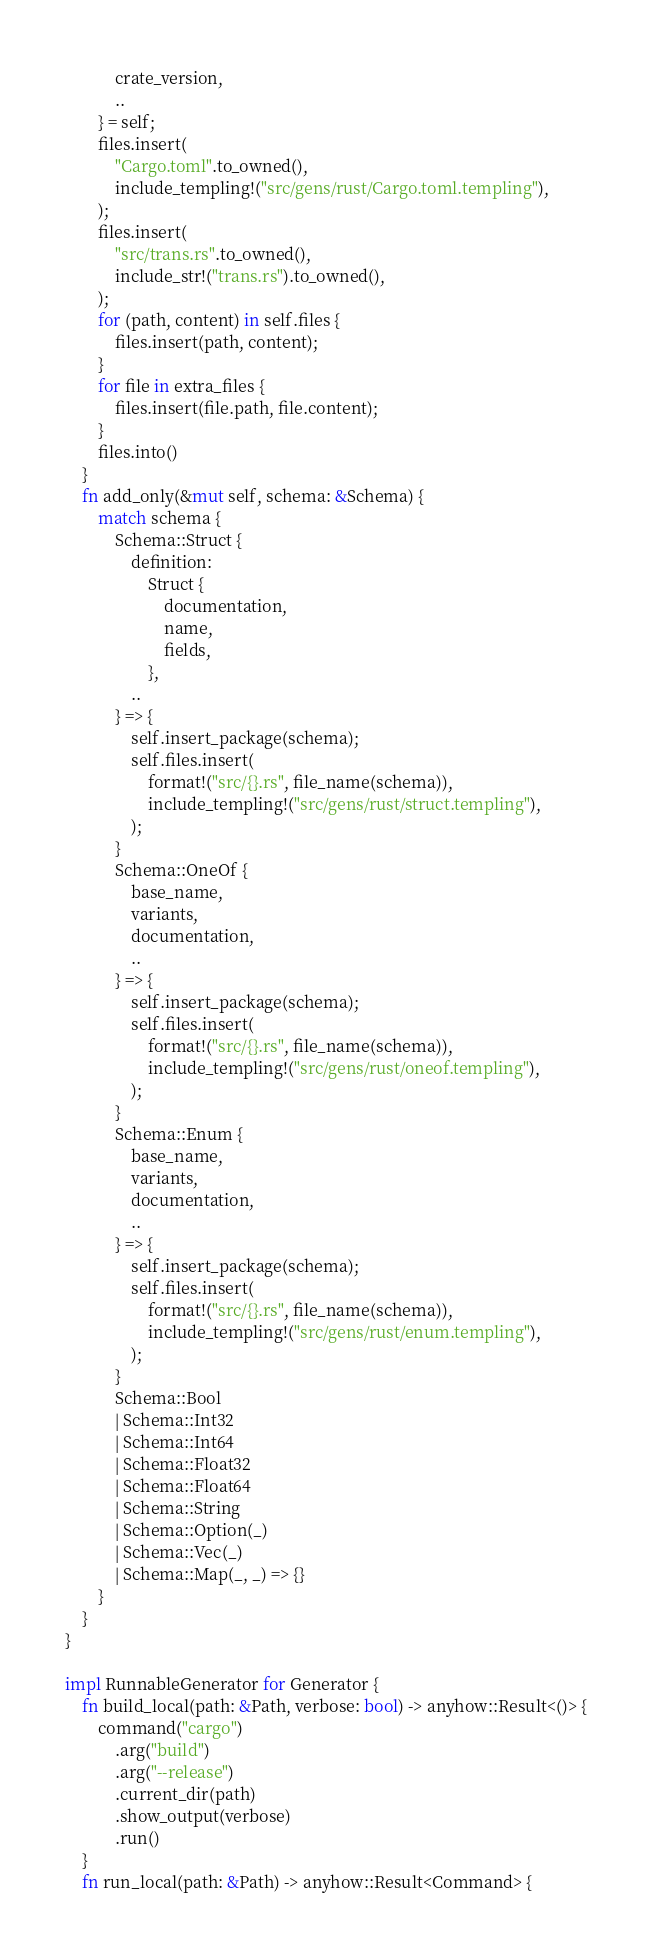<code> <loc_0><loc_0><loc_500><loc_500><_Rust_>            crate_version,
            ..
        } = self;
        files.insert(
            "Cargo.toml".to_owned(),
            include_templing!("src/gens/rust/Cargo.toml.templing"),
        );
        files.insert(
            "src/trans.rs".to_owned(),
            include_str!("trans.rs").to_owned(),
        );
        for (path, content) in self.files {
            files.insert(path, content);
        }
        for file in extra_files {
            files.insert(file.path, file.content);
        }
        files.into()
    }
    fn add_only(&mut self, schema: &Schema) {
        match schema {
            Schema::Struct {
                definition:
                    Struct {
                        documentation,
                        name,
                        fields,
                    },
                ..
            } => {
                self.insert_package(schema);
                self.files.insert(
                    format!("src/{}.rs", file_name(schema)),
                    include_templing!("src/gens/rust/struct.templing"),
                );
            }
            Schema::OneOf {
                base_name,
                variants,
                documentation,
                ..
            } => {
                self.insert_package(schema);
                self.files.insert(
                    format!("src/{}.rs", file_name(schema)),
                    include_templing!("src/gens/rust/oneof.templing"),
                );
            }
            Schema::Enum {
                base_name,
                variants,
                documentation,
                ..
            } => {
                self.insert_package(schema);
                self.files.insert(
                    format!("src/{}.rs", file_name(schema)),
                    include_templing!("src/gens/rust/enum.templing"),
                );
            }
            Schema::Bool
            | Schema::Int32
            | Schema::Int64
            | Schema::Float32
            | Schema::Float64
            | Schema::String
            | Schema::Option(_)
            | Schema::Vec(_)
            | Schema::Map(_, _) => {}
        }
    }
}

impl RunnableGenerator for Generator {
    fn build_local(path: &Path, verbose: bool) -> anyhow::Result<()> {
        command("cargo")
            .arg("build")
            .arg("--release")
            .current_dir(path)
            .show_output(verbose)
            .run()
    }
    fn run_local(path: &Path) -> anyhow::Result<Command> {</code> 